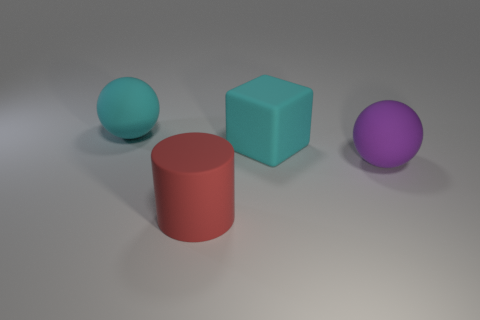Add 3 cyan spheres. How many objects exist? 7 Subtract all cubes. How many objects are left? 3 Subtract 1 cyan spheres. How many objects are left? 3 Subtract all purple objects. Subtract all small red metallic cylinders. How many objects are left? 3 Add 3 purple matte spheres. How many purple matte spheres are left? 4 Add 4 brown rubber cylinders. How many brown rubber cylinders exist? 4 